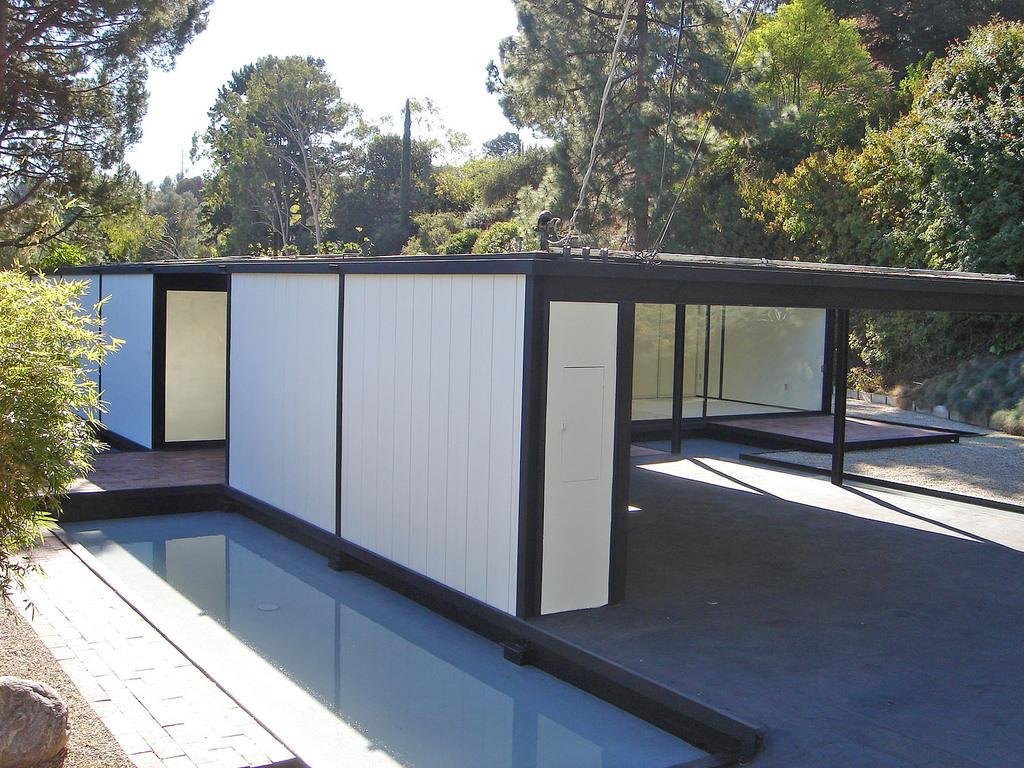What type of furniture is present in the image? There are tables in the image. What object can be seen hanging or tied in the image? There is a rope in the image. What type of container is visible in the image? There is a glass in the image. What type of natural object is present in the image? There is a stone in the image. What can be seen in the distance in the image? There are trees in the background of the image. What is visible in the sky in the image? The sky is visible in the background of the image. What type of pollution is visible in the image? There is no visible pollution in the image. Can you tell me how many basketballs are present in the image? There are no basketballs present in the image. 